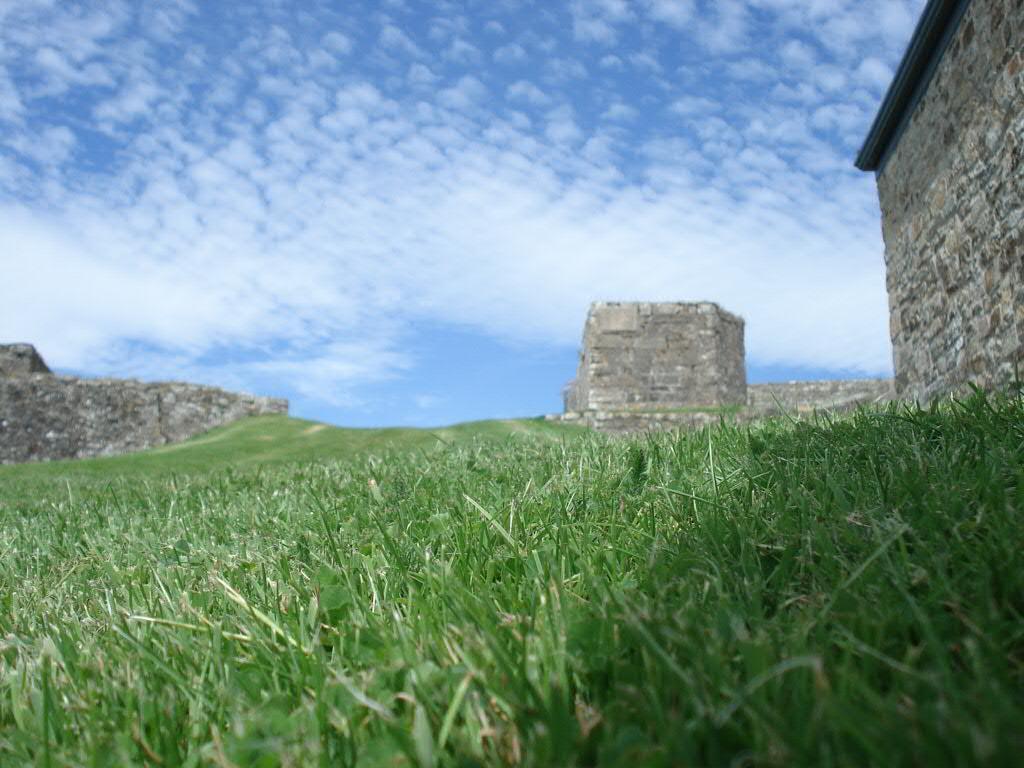Could you give a brief overview of what you see in this image? In this image we can see a few Ruins, some green grass on the ground and at the top there is the cloudy sky. 